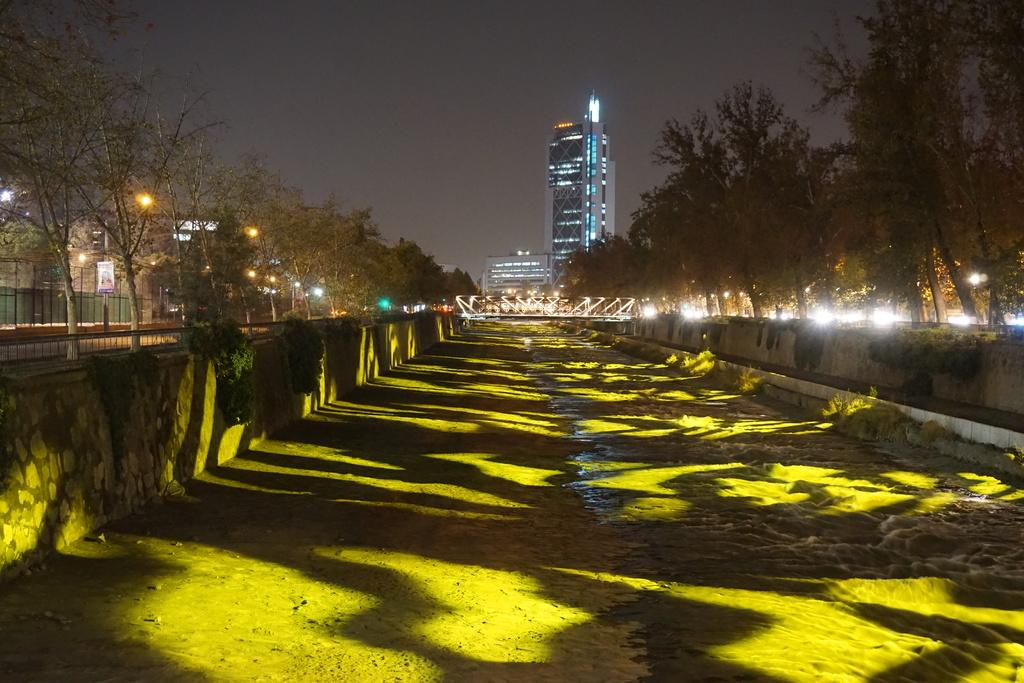What body of water is visible in the image? There is a lake in the image. What type of vegetation surrounds the lake? There are trees on either side of the lake. What type of infrastructure is present near the lake? There are roads on either side of the lake. What can be seen in the background of the image? There is a bridge and a building in the background of the image. Can you see any goldfish swimming in the lake in the image? There is no indication of goldfish in the image; it only shows a lake with trees, roads, a bridge, and a building in the background. 